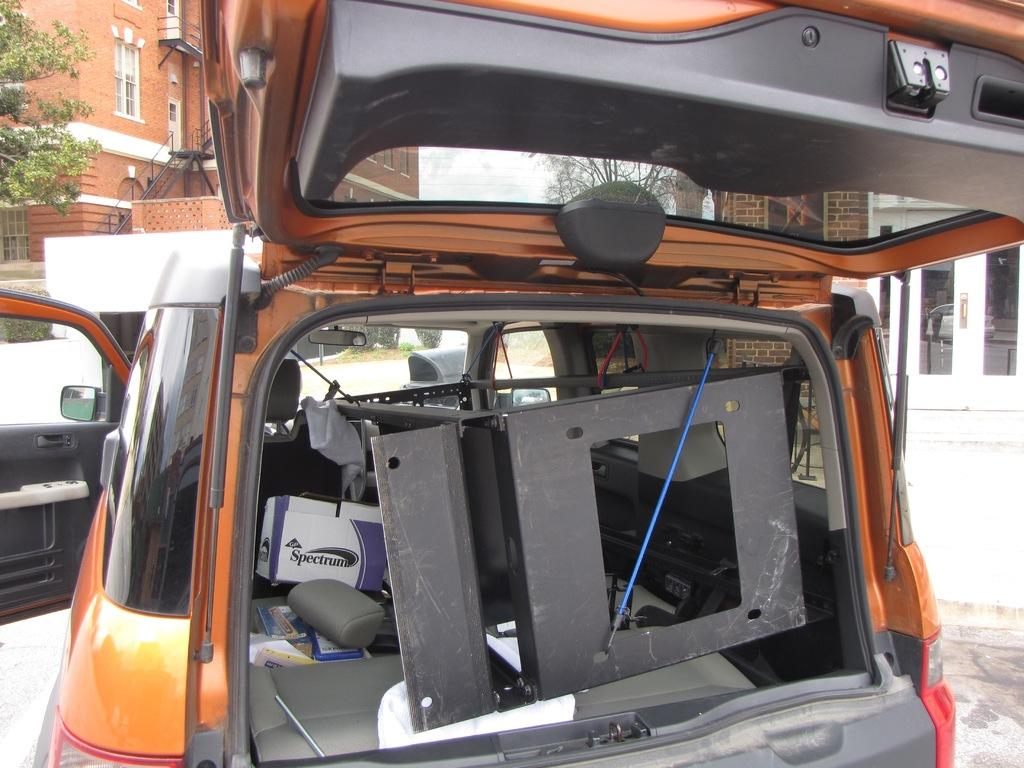What is on the road in the image? There is a vehicle on the road in the image. What can be found inside the vehicle? The vehicle contains some objects. What can be seen in the distance behind the vehicle? There are buildings and trees in the background of the image. What features do the buildings have? The buildings have windows and doors. Can you see the father knitting wool in the image? There is no father or knitting wool present in the image. Is there a snail crawling on the vehicle in the image? There is no snail visible on the vehicle in the image. 